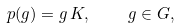Convert formula to latex. <formula><loc_0><loc_0><loc_500><loc_500>p ( g ) = g \, K , \quad g \in G ,</formula> 